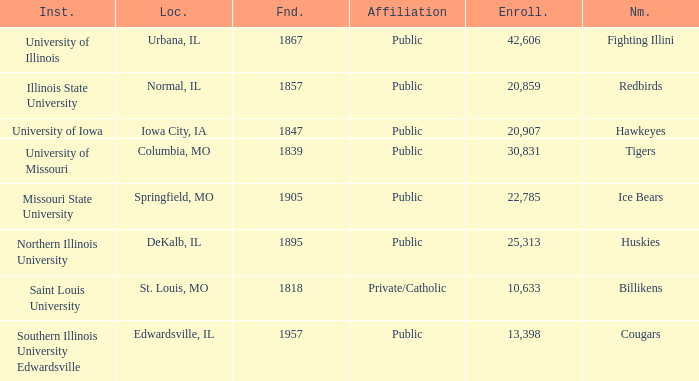What is the average enrollment of the Redbirds' school? 20859.0. Parse the full table. {'header': ['Inst.', 'Loc.', 'Fnd.', 'Affiliation', 'Enroll.', 'Nm.'], 'rows': [['University of Illinois', 'Urbana, IL', '1867', 'Public', '42,606', 'Fighting Illini'], ['Illinois State University', 'Normal, IL', '1857', 'Public', '20,859', 'Redbirds'], ['University of Iowa', 'Iowa City, IA', '1847', 'Public', '20,907', 'Hawkeyes'], ['University of Missouri', 'Columbia, MO', '1839', 'Public', '30,831', 'Tigers'], ['Missouri State University', 'Springfield, MO', '1905', 'Public', '22,785', 'Ice Bears'], ['Northern Illinois University', 'DeKalb, IL', '1895', 'Public', '25,313', 'Huskies'], ['Saint Louis University', 'St. Louis, MO', '1818', 'Private/Catholic', '10,633', 'Billikens'], ['Southern Illinois University Edwardsville', 'Edwardsville, IL', '1957', 'Public', '13,398', 'Cougars']]} 